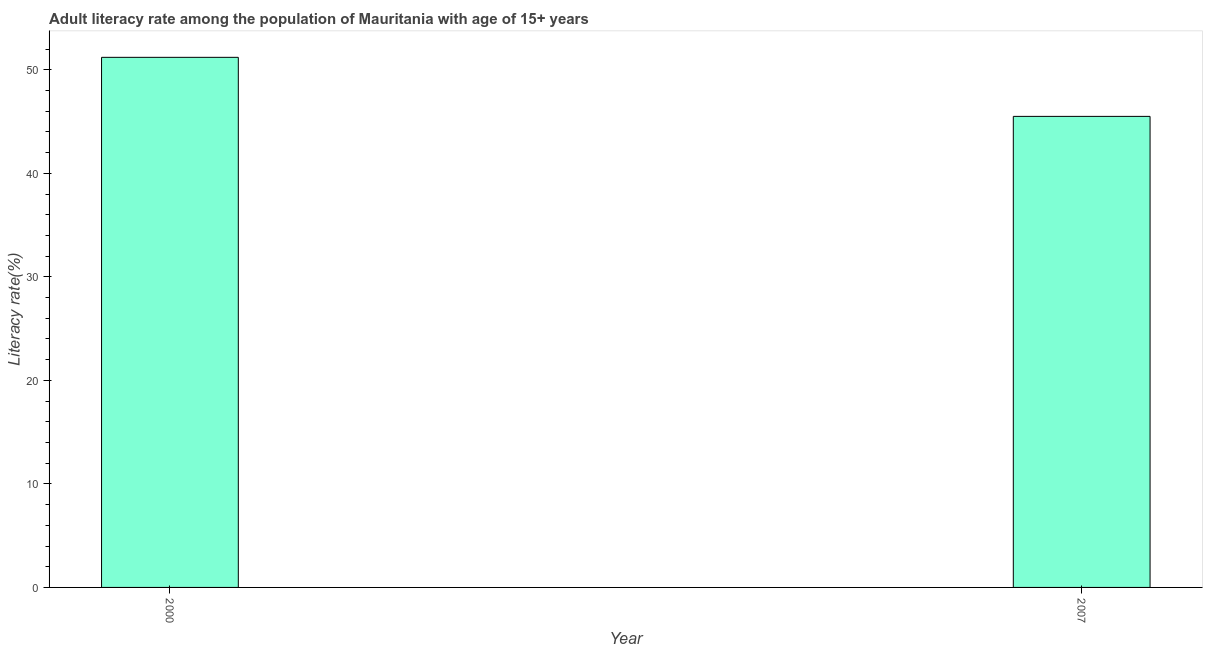Does the graph contain any zero values?
Offer a terse response. No. Does the graph contain grids?
Make the answer very short. No. What is the title of the graph?
Provide a short and direct response. Adult literacy rate among the population of Mauritania with age of 15+ years. What is the label or title of the Y-axis?
Offer a terse response. Literacy rate(%). What is the adult literacy rate in 2007?
Ensure brevity in your answer.  45.5. Across all years, what is the maximum adult literacy rate?
Provide a short and direct response. 51.21. Across all years, what is the minimum adult literacy rate?
Give a very brief answer. 45.5. In which year was the adult literacy rate maximum?
Offer a very short reply. 2000. What is the sum of the adult literacy rate?
Your answer should be compact. 96.71. What is the difference between the adult literacy rate in 2000 and 2007?
Your answer should be compact. 5.7. What is the average adult literacy rate per year?
Ensure brevity in your answer.  48.36. What is the median adult literacy rate?
Offer a very short reply. 48.36. Do a majority of the years between 2000 and 2007 (inclusive) have adult literacy rate greater than 20 %?
Make the answer very short. Yes. In how many years, is the adult literacy rate greater than the average adult literacy rate taken over all years?
Keep it short and to the point. 1. How many bars are there?
Your answer should be very brief. 2. Are all the bars in the graph horizontal?
Keep it short and to the point. No. What is the difference between two consecutive major ticks on the Y-axis?
Keep it short and to the point. 10. What is the Literacy rate(%) in 2000?
Ensure brevity in your answer.  51.21. What is the Literacy rate(%) of 2007?
Ensure brevity in your answer.  45.5. What is the difference between the Literacy rate(%) in 2000 and 2007?
Provide a short and direct response. 5.7. What is the ratio of the Literacy rate(%) in 2000 to that in 2007?
Your answer should be compact. 1.12. 